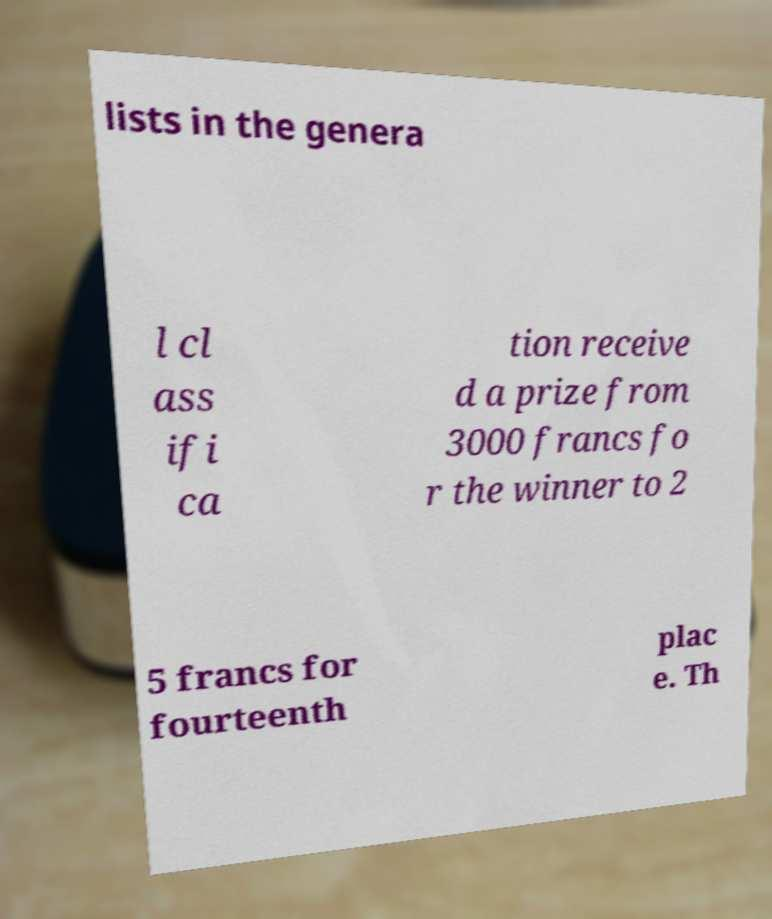I need the written content from this picture converted into text. Can you do that? lists in the genera l cl ass ifi ca tion receive d a prize from 3000 francs fo r the winner to 2 5 francs for fourteenth plac e. Th 